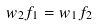Convert formula to latex. <formula><loc_0><loc_0><loc_500><loc_500>w _ { 2 } f _ { 1 } = w _ { 1 } f _ { 2 }</formula> 